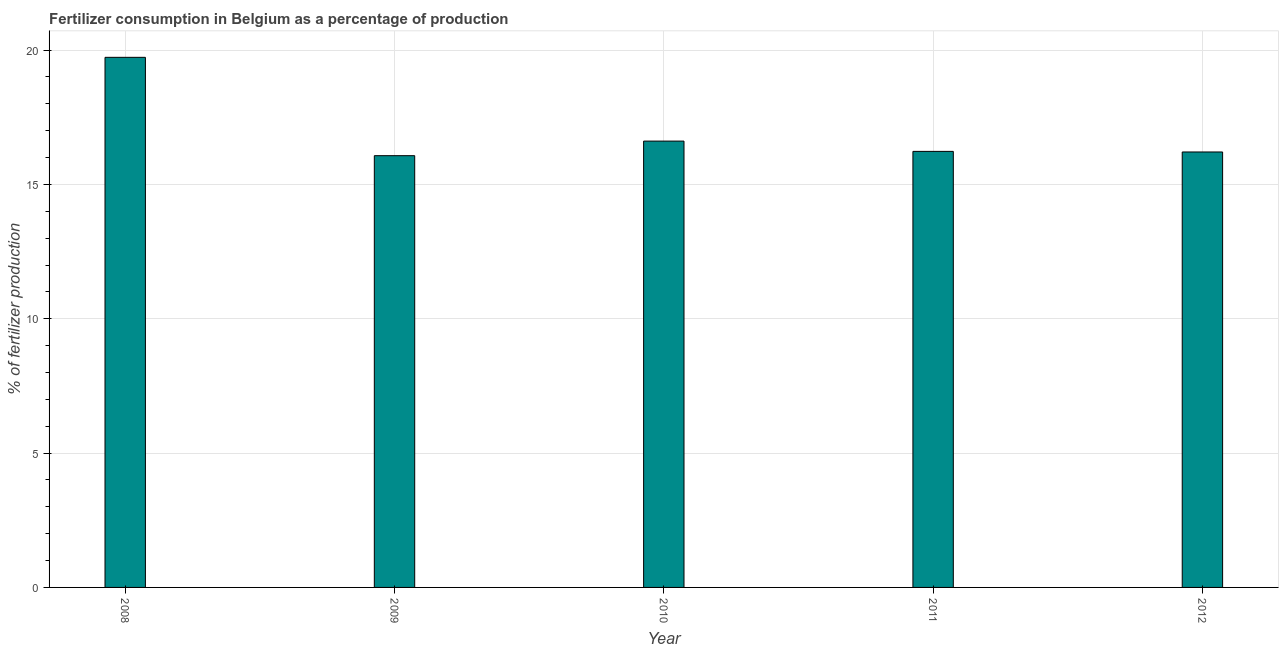Does the graph contain grids?
Give a very brief answer. Yes. What is the title of the graph?
Keep it short and to the point. Fertilizer consumption in Belgium as a percentage of production. What is the label or title of the X-axis?
Give a very brief answer. Year. What is the label or title of the Y-axis?
Give a very brief answer. % of fertilizer production. What is the amount of fertilizer consumption in 2010?
Make the answer very short. 16.61. Across all years, what is the maximum amount of fertilizer consumption?
Your response must be concise. 19.73. Across all years, what is the minimum amount of fertilizer consumption?
Ensure brevity in your answer.  16.07. In which year was the amount of fertilizer consumption minimum?
Your answer should be very brief. 2009. What is the sum of the amount of fertilizer consumption?
Make the answer very short. 84.85. What is the difference between the amount of fertilizer consumption in 2008 and 2012?
Your response must be concise. 3.52. What is the average amount of fertilizer consumption per year?
Your response must be concise. 16.97. What is the median amount of fertilizer consumption?
Provide a succinct answer. 16.23. What is the ratio of the amount of fertilizer consumption in 2008 to that in 2011?
Provide a succinct answer. 1.22. What is the difference between the highest and the second highest amount of fertilizer consumption?
Make the answer very short. 3.12. What is the difference between the highest and the lowest amount of fertilizer consumption?
Provide a succinct answer. 3.66. In how many years, is the amount of fertilizer consumption greater than the average amount of fertilizer consumption taken over all years?
Provide a short and direct response. 1. Are the values on the major ticks of Y-axis written in scientific E-notation?
Your response must be concise. No. What is the % of fertilizer production of 2008?
Ensure brevity in your answer.  19.73. What is the % of fertilizer production of 2009?
Keep it short and to the point. 16.07. What is the % of fertilizer production of 2010?
Offer a very short reply. 16.61. What is the % of fertilizer production of 2011?
Provide a short and direct response. 16.23. What is the % of fertilizer production of 2012?
Your answer should be compact. 16.21. What is the difference between the % of fertilizer production in 2008 and 2009?
Your answer should be compact. 3.66. What is the difference between the % of fertilizer production in 2008 and 2010?
Make the answer very short. 3.12. What is the difference between the % of fertilizer production in 2008 and 2011?
Your answer should be compact. 3.5. What is the difference between the % of fertilizer production in 2008 and 2012?
Offer a very short reply. 3.52. What is the difference between the % of fertilizer production in 2009 and 2010?
Keep it short and to the point. -0.54. What is the difference between the % of fertilizer production in 2009 and 2011?
Give a very brief answer. -0.16. What is the difference between the % of fertilizer production in 2009 and 2012?
Your answer should be compact. -0.14. What is the difference between the % of fertilizer production in 2010 and 2011?
Ensure brevity in your answer.  0.38. What is the difference between the % of fertilizer production in 2010 and 2012?
Your answer should be very brief. 0.4. What is the difference between the % of fertilizer production in 2011 and 2012?
Offer a very short reply. 0.02. What is the ratio of the % of fertilizer production in 2008 to that in 2009?
Offer a terse response. 1.23. What is the ratio of the % of fertilizer production in 2008 to that in 2010?
Your answer should be very brief. 1.19. What is the ratio of the % of fertilizer production in 2008 to that in 2011?
Ensure brevity in your answer.  1.22. What is the ratio of the % of fertilizer production in 2008 to that in 2012?
Make the answer very short. 1.22. What is the ratio of the % of fertilizer production in 2010 to that in 2012?
Provide a short and direct response. 1.02. What is the ratio of the % of fertilizer production in 2011 to that in 2012?
Provide a short and direct response. 1. 